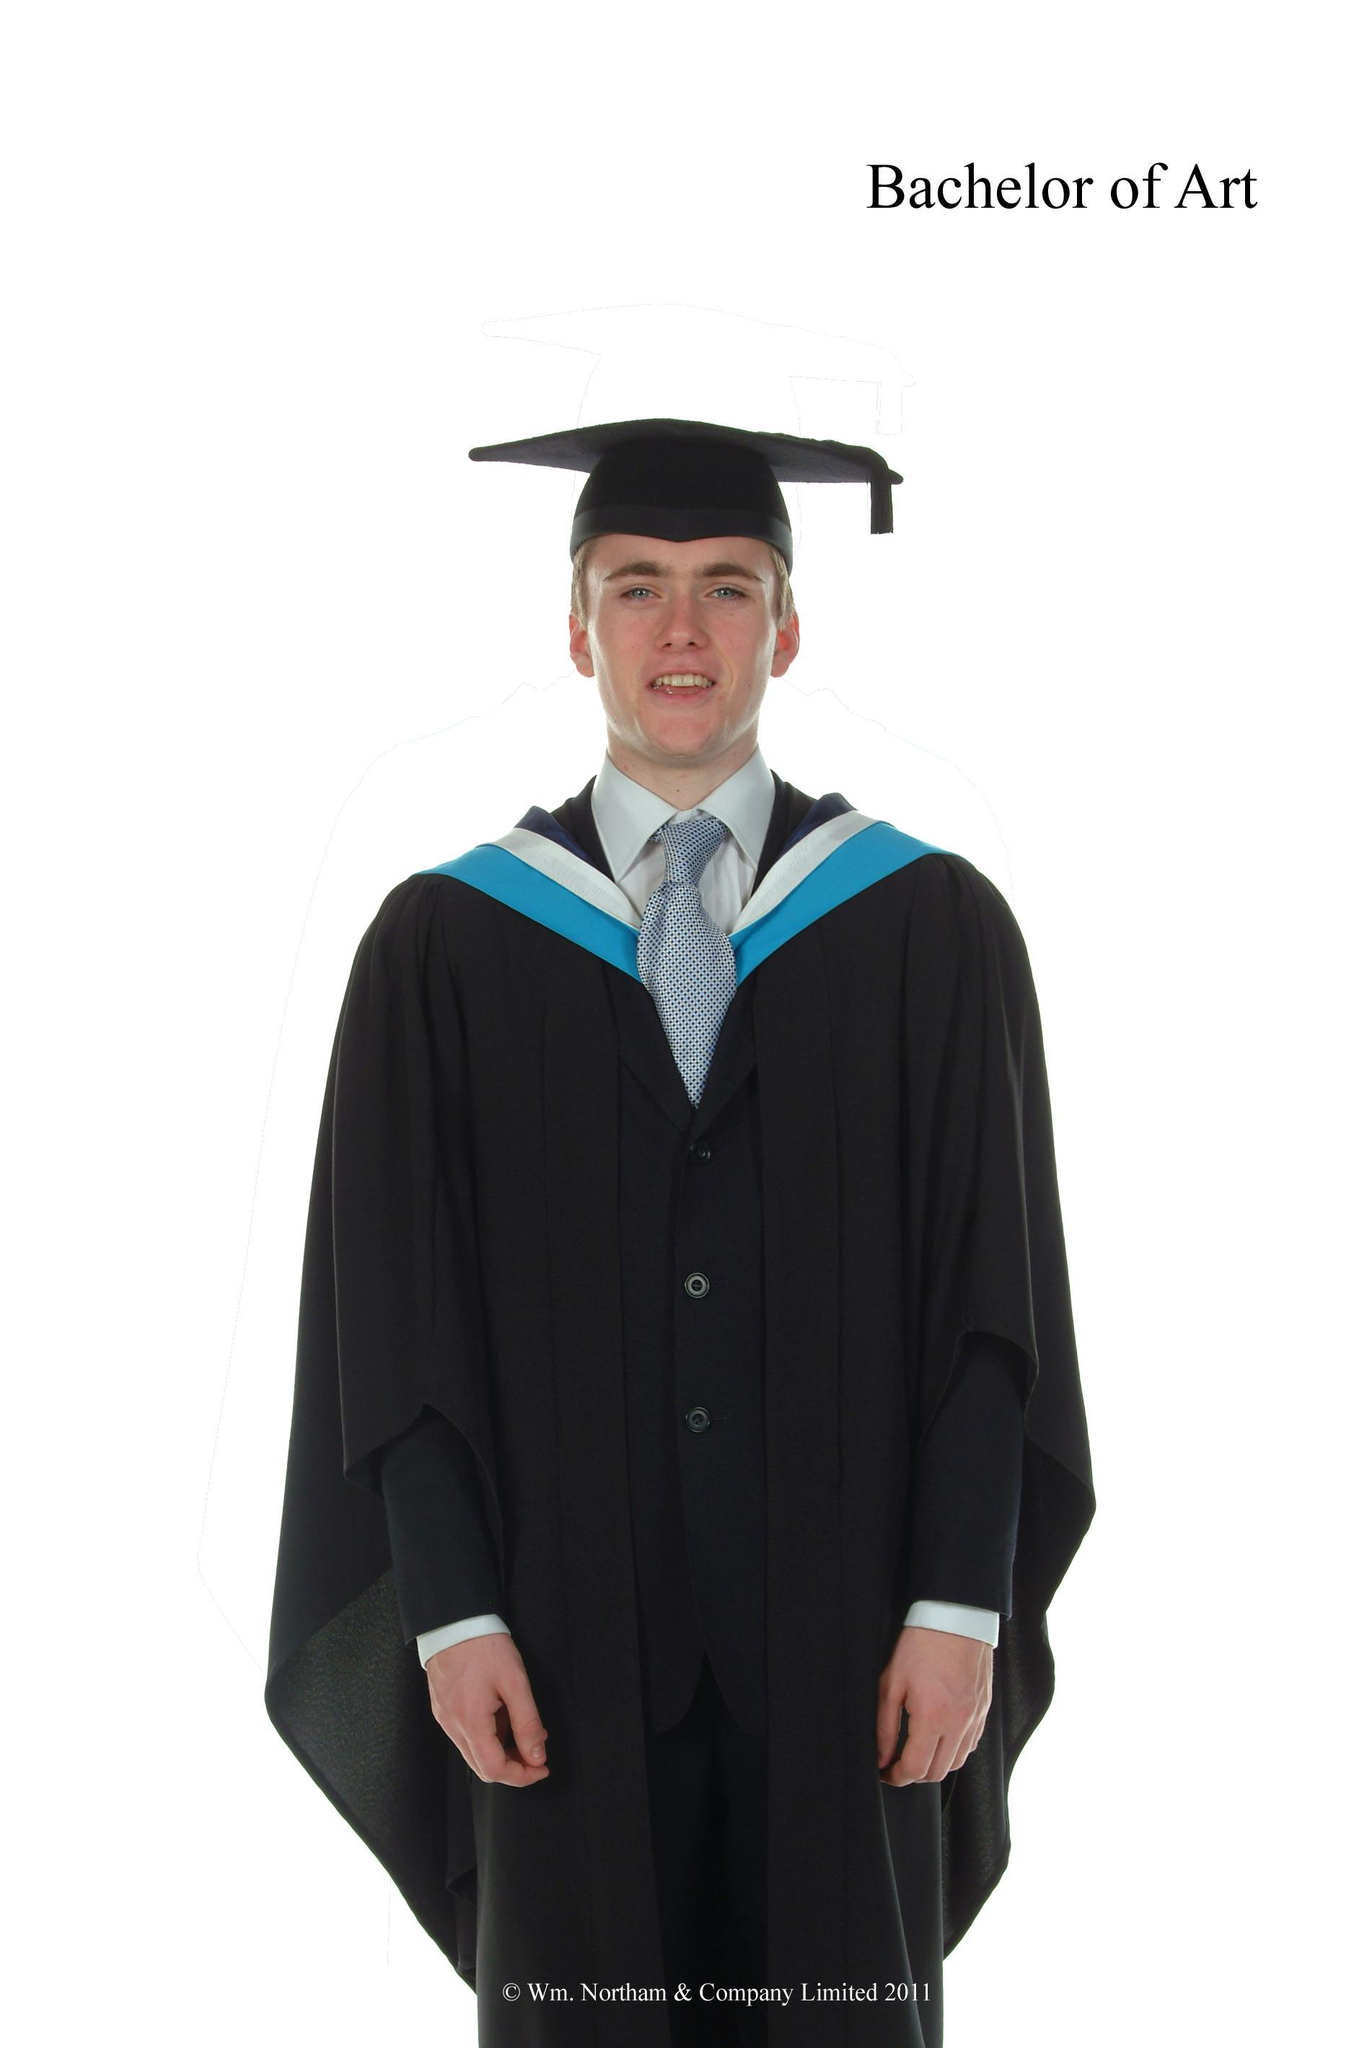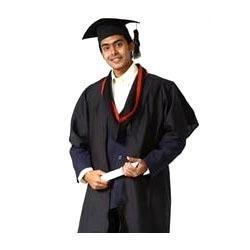The first image is the image on the left, the second image is the image on the right. Analyze the images presented: Is the assertion "White sleeves are almost completely exposed in one of the images." valid? Answer yes or no. No. 